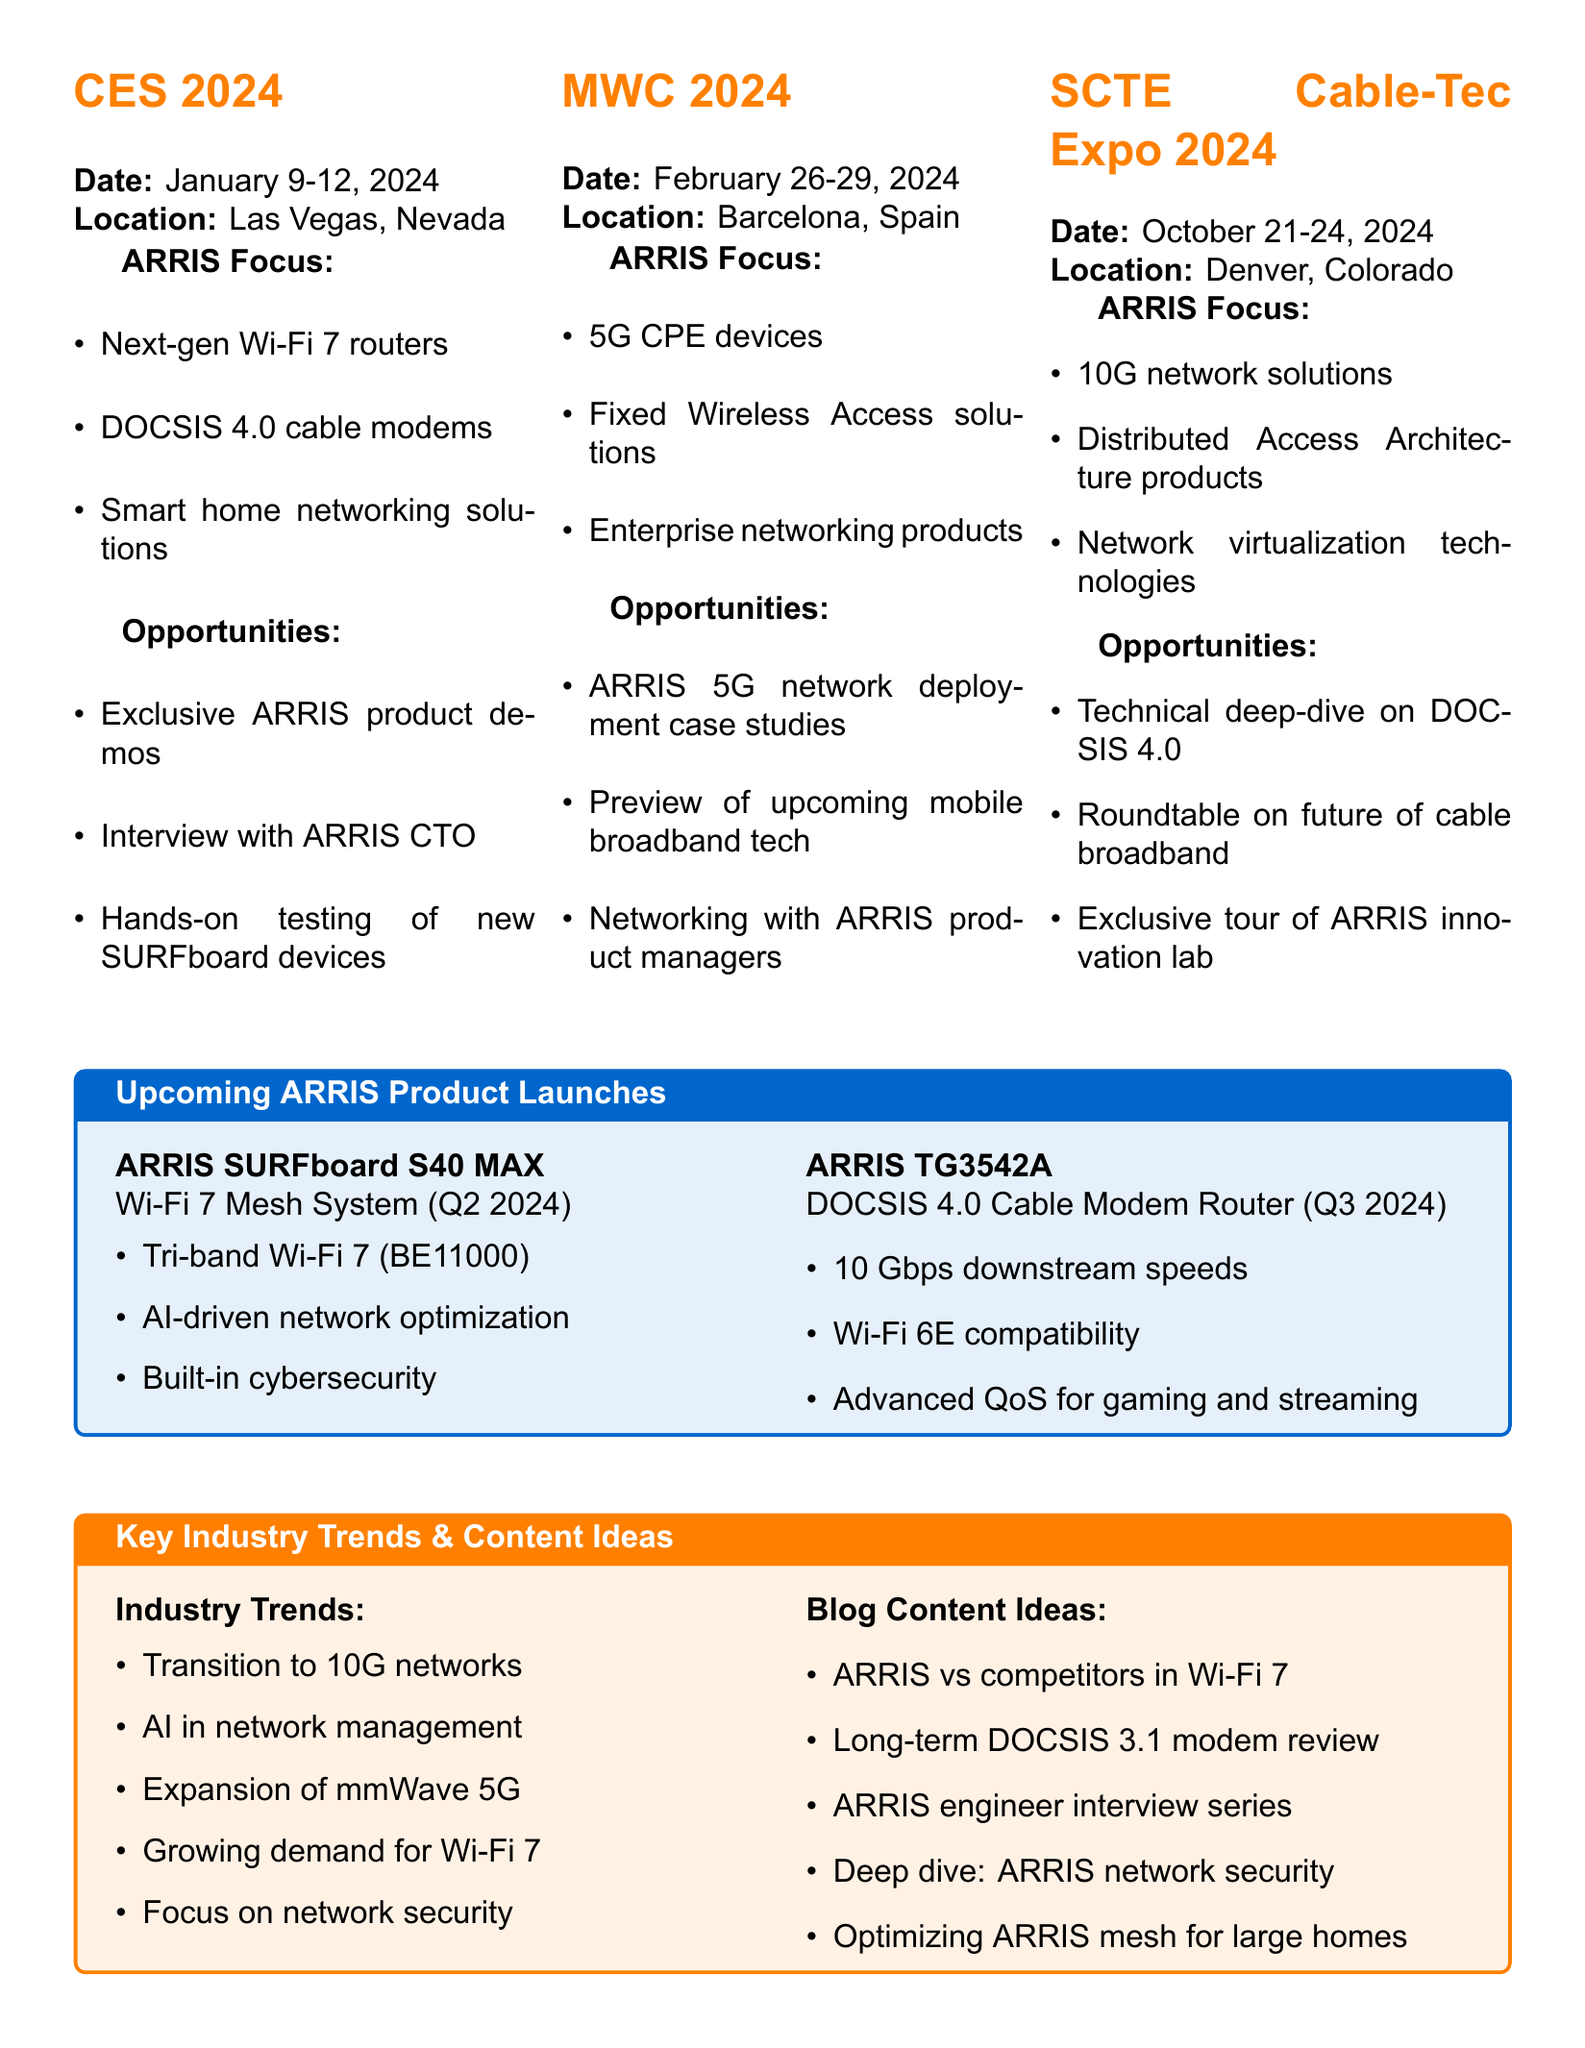what are the dates for CES 2024? The dates for CES 2024 are stated in the agenda section, which shows "January 9-12, 2024."
Answer: January 9-12, 2024 where is Mobile World Congress 2024 taking place? The location for Mobile World Congress 2024 is mentioned in the respective section, which is "Barcelona, Spain."
Answer: Barcelona, Spain what product is expected to launch in Q2 2024? The agenda notes the upcoming ARRIS product launches, identifying "ARRIS SURFboard S40 MAX" for Q2 2024.
Answer: ARRIS SURFboard S40 MAX what is one feature of the ARRIS TG3542A? One of the key features of the ARRIS TG3542A is listed as "10 Gbps downstream speeds" in the product launch details.
Answer: 10 Gbps downstream speeds which technology is highlighted in the ARRIS focus at SCTE Cable-Tec Expo 2024? One of the points of ARRIS focus at SCTE Cable-Tec Expo 2024 is "10G network solutions" as listed in the agenda.
Answer: 10G network solutions what is one opportunity for bloggers at CES 2024? The document specifies opportunities for bloggers at CES 2024, including "Exclusive ARRIS product demos."
Answer: Exclusive ARRIS product demos how many industry trends are listed? The document provides a list of industry trends, which includes "five" items.
Answer: five what is the focus of ARRIS at Mobile World Congress 2024? The focus areas for ARRIS at Mobile World Congress 2024 include the highlighted items such as "5G CPE devices."
Answer: 5G CPE devices what type of document is this agenda? The structure and content indicate this document is an "agenda" specifically for "Tech Trade Shows."
Answer: agenda 